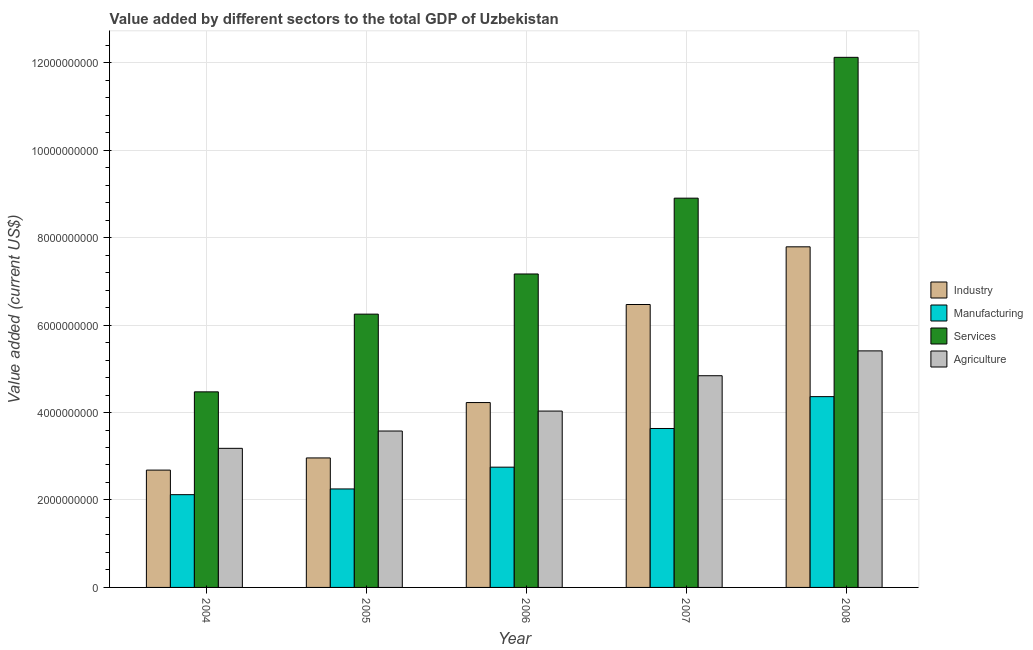How many different coloured bars are there?
Keep it short and to the point. 4. How many bars are there on the 1st tick from the left?
Offer a very short reply. 4. How many bars are there on the 5th tick from the right?
Keep it short and to the point. 4. What is the value added by services sector in 2004?
Provide a short and direct response. 4.47e+09. Across all years, what is the maximum value added by services sector?
Provide a succinct answer. 1.21e+1. Across all years, what is the minimum value added by manufacturing sector?
Provide a succinct answer. 2.12e+09. What is the total value added by manufacturing sector in the graph?
Your answer should be compact. 1.51e+1. What is the difference between the value added by manufacturing sector in 2004 and that in 2006?
Ensure brevity in your answer.  -6.29e+08. What is the difference between the value added by agricultural sector in 2005 and the value added by services sector in 2007?
Make the answer very short. -1.26e+09. What is the average value added by agricultural sector per year?
Make the answer very short. 4.21e+09. In the year 2008, what is the difference between the value added by manufacturing sector and value added by industrial sector?
Make the answer very short. 0. What is the ratio of the value added by agricultural sector in 2005 to that in 2006?
Provide a succinct answer. 0.89. Is the difference between the value added by industrial sector in 2004 and 2008 greater than the difference between the value added by services sector in 2004 and 2008?
Offer a terse response. No. What is the difference between the highest and the second highest value added by services sector?
Give a very brief answer. 3.22e+09. What is the difference between the highest and the lowest value added by agricultural sector?
Provide a short and direct response. 2.23e+09. What does the 1st bar from the left in 2005 represents?
Offer a terse response. Industry. What does the 3rd bar from the right in 2005 represents?
Keep it short and to the point. Manufacturing. Is it the case that in every year, the sum of the value added by industrial sector and value added by manufacturing sector is greater than the value added by services sector?
Your answer should be very brief. No. Are all the bars in the graph horizontal?
Offer a terse response. No. Does the graph contain any zero values?
Give a very brief answer. No. How are the legend labels stacked?
Give a very brief answer. Vertical. What is the title of the graph?
Your answer should be compact. Value added by different sectors to the total GDP of Uzbekistan. Does "Third 20% of population" appear as one of the legend labels in the graph?
Your answer should be very brief. No. What is the label or title of the X-axis?
Make the answer very short. Year. What is the label or title of the Y-axis?
Provide a succinct answer. Value added (current US$). What is the Value added (current US$) of Industry in 2004?
Offer a terse response. 2.68e+09. What is the Value added (current US$) in Manufacturing in 2004?
Your answer should be compact. 2.12e+09. What is the Value added (current US$) of Services in 2004?
Keep it short and to the point. 4.47e+09. What is the Value added (current US$) of Agriculture in 2004?
Ensure brevity in your answer.  3.18e+09. What is the Value added (current US$) in Industry in 2005?
Your answer should be compact. 2.96e+09. What is the Value added (current US$) of Manufacturing in 2005?
Provide a short and direct response. 2.25e+09. What is the Value added (current US$) of Services in 2005?
Your answer should be very brief. 6.25e+09. What is the Value added (current US$) in Agriculture in 2005?
Keep it short and to the point. 3.58e+09. What is the Value added (current US$) in Industry in 2006?
Make the answer very short. 4.23e+09. What is the Value added (current US$) of Manufacturing in 2006?
Your response must be concise. 2.75e+09. What is the Value added (current US$) in Services in 2006?
Your answer should be compact. 7.17e+09. What is the Value added (current US$) of Agriculture in 2006?
Give a very brief answer. 4.03e+09. What is the Value added (current US$) of Industry in 2007?
Provide a succinct answer. 6.47e+09. What is the Value added (current US$) of Manufacturing in 2007?
Provide a short and direct response. 3.64e+09. What is the Value added (current US$) of Services in 2007?
Give a very brief answer. 8.90e+09. What is the Value added (current US$) of Agriculture in 2007?
Provide a succinct answer. 4.84e+09. What is the Value added (current US$) in Industry in 2008?
Provide a succinct answer. 7.79e+09. What is the Value added (current US$) in Manufacturing in 2008?
Make the answer very short. 4.36e+09. What is the Value added (current US$) in Services in 2008?
Keep it short and to the point. 1.21e+1. What is the Value added (current US$) in Agriculture in 2008?
Keep it short and to the point. 5.41e+09. Across all years, what is the maximum Value added (current US$) in Industry?
Your response must be concise. 7.79e+09. Across all years, what is the maximum Value added (current US$) in Manufacturing?
Make the answer very short. 4.36e+09. Across all years, what is the maximum Value added (current US$) in Services?
Give a very brief answer. 1.21e+1. Across all years, what is the maximum Value added (current US$) of Agriculture?
Ensure brevity in your answer.  5.41e+09. Across all years, what is the minimum Value added (current US$) in Industry?
Your answer should be compact. 2.68e+09. Across all years, what is the minimum Value added (current US$) of Manufacturing?
Your answer should be very brief. 2.12e+09. Across all years, what is the minimum Value added (current US$) in Services?
Make the answer very short. 4.47e+09. Across all years, what is the minimum Value added (current US$) in Agriculture?
Your answer should be compact. 3.18e+09. What is the total Value added (current US$) in Industry in the graph?
Your answer should be very brief. 2.41e+1. What is the total Value added (current US$) of Manufacturing in the graph?
Offer a terse response. 1.51e+1. What is the total Value added (current US$) in Services in the graph?
Provide a succinct answer. 3.89e+1. What is the total Value added (current US$) of Agriculture in the graph?
Your answer should be compact. 2.10e+1. What is the difference between the Value added (current US$) of Industry in 2004 and that in 2005?
Offer a very short reply. -2.78e+08. What is the difference between the Value added (current US$) in Manufacturing in 2004 and that in 2005?
Ensure brevity in your answer.  -1.31e+08. What is the difference between the Value added (current US$) in Services in 2004 and that in 2005?
Ensure brevity in your answer.  -1.78e+09. What is the difference between the Value added (current US$) of Agriculture in 2004 and that in 2005?
Your answer should be compact. -3.96e+08. What is the difference between the Value added (current US$) in Industry in 2004 and that in 2006?
Ensure brevity in your answer.  -1.54e+09. What is the difference between the Value added (current US$) of Manufacturing in 2004 and that in 2006?
Provide a short and direct response. -6.29e+08. What is the difference between the Value added (current US$) of Services in 2004 and that in 2006?
Make the answer very short. -2.70e+09. What is the difference between the Value added (current US$) of Agriculture in 2004 and that in 2006?
Give a very brief answer. -8.52e+08. What is the difference between the Value added (current US$) in Industry in 2004 and that in 2007?
Make the answer very short. -3.79e+09. What is the difference between the Value added (current US$) of Manufacturing in 2004 and that in 2007?
Provide a succinct answer. -1.51e+09. What is the difference between the Value added (current US$) of Services in 2004 and that in 2007?
Provide a short and direct response. -4.43e+09. What is the difference between the Value added (current US$) of Agriculture in 2004 and that in 2007?
Give a very brief answer. -1.66e+09. What is the difference between the Value added (current US$) in Industry in 2004 and that in 2008?
Provide a succinct answer. -5.11e+09. What is the difference between the Value added (current US$) in Manufacturing in 2004 and that in 2008?
Keep it short and to the point. -2.24e+09. What is the difference between the Value added (current US$) of Services in 2004 and that in 2008?
Provide a short and direct response. -7.65e+09. What is the difference between the Value added (current US$) of Agriculture in 2004 and that in 2008?
Keep it short and to the point. -2.23e+09. What is the difference between the Value added (current US$) of Industry in 2005 and that in 2006?
Your answer should be very brief. -1.27e+09. What is the difference between the Value added (current US$) of Manufacturing in 2005 and that in 2006?
Give a very brief answer. -4.98e+08. What is the difference between the Value added (current US$) in Services in 2005 and that in 2006?
Offer a very short reply. -9.18e+08. What is the difference between the Value added (current US$) of Agriculture in 2005 and that in 2006?
Make the answer very short. -4.56e+08. What is the difference between the Value added (current US$) in Industry in 2005 and that in 2007?
Your response must be concise. -3.51e+09. What is the difference between the Value added (current US$) in Manufacturing in 2005 and that in 2007?
Provide a short and direct response. -1.38e+09. What is the difference between the Value added (current US$) of Services in 2005 and that in 2007?
Your answer should be very brief. -2.65e+09. What is the difference between the Value added (current US$) in Agriculture in 2005 and that in 2007?
Your answer should be compact. -1.26e+09. What is the difference between the Value added (current US$) in Industry in 2005 and that in 2008?
Ensure brevity in your answer.  -4.83e+09. What is the difference between the Value added (current US$) in Manufacturing in 2005 and that in 2008?
Give a very brief answer. -2.11e+09. What is the difference between the Value added (current US$) of Services in 2005 and that in 2008?
Ensure brevity in your answer.  -5.87e+09. What is the difference between the Value added (current US$) in Agriculture in 2005 and that in 2008?
Keep it short and to the point. -1.83e+09. What is the difference between the Value added (current US$) in Industry in 2006 and that in 2007?
Provide a succinct answer. -2.24e+09. What is the difference between the Value added (current US$) in Manufacturing in 2006 and that in 2007?
Provide a succinct answer. -8.85e+08. What is the difference between the Value added (current US$) in Services in 2006 and that in 2007?
Provide a short and direct response. -1.73e+09. What is the difference between the Value added (current US$) of Agriculture in 2006 and that in 2007?
Give a very brief answer. -8.08e+08. What is the difference between the Value added (current US$) of Industry in 2006 and that in 2008?
Keep it short and to the point. -3.56e+09. What is the difference between the Value added (current US$) in Manufacturing in 2006 and that in 2008?
Your answer should be compact. -1.61e+09. What is the difference between the Value added (current US$) in Services in 2006 and that in 2008?
Make the answer very short. -4.95e+09. What is the difference between the Value added (current US$) in Agriculture in 2006 and that in 2008?
Your answer should be very brief. -1.38e+09. What is the difference between the Value added (current US$) in Industry in 2007 and that in 2008?
Ensure brevity in your answer.  -1.32e+09. What is the difference between the Value added (current US$) in Manufacturing in 2007 and that in 2008?
Make the answer very short. -7.29e+08. What is the difference between the Value added (current US$) of Services in 2007 and that in 2008?
Offer a terse response. -3.22e+09. What is the difference between the Value added (current US$) in Agriculture in 2007 and that in 2008?
Make the answer very short. -5.68e+08. What is the difference between the Value added (current US$) in Industry in 2004 and the Value added (current US$) in Manufacturing in 2005?
Your answer should be very brief. 4.31e+08. What is the difference between the Value added (current US$) in Industry in 2004 and the Value added (current US$) in Services in 2005?
Provide a short and direct response. -3.57e+09. What is the difference between the Value added (current US$) in Industry in 2004 and the Value added (current US$) in Agriculture in 2005?
Ensure brevity in your answer.  -8.93e+08. What is the difference between the Value added (current US$) in Manufacturing in 2004 and the Value added (current US$) in Services in 2005?
Your answer should be compact. -4.13e+09. What is the difference between the Value added (current US$) in Manufacturing in 2004 and the Value added (current US$) in Agriculture in 2005?
Your response must be concise. -1.46e+09. What is the difference between the Value added (current US$) in Services in 2004 and the Value added (current US$) in Agriculture in 2005?
Offer a terse response. 8.96e+08. What is the difference between the Value added (current US$) of Industry in 2004 and the Value added (current US$) of Manufacturing in 2006?
Provide a succinct answer. -6.70e+07. What is the difference between the Value added (current US$) in Industry in 2004 and the Value added (current US$) in Services in 2006?
Your answer should be very brief. -4.49e+09. What is the difference between the Value added (current US$) in Industry in 2004 and the Value added (current US$) in Agriculture in 2006?
Offer a terse response. -1.35e+09. What is the difference between the Value added (current US$) in Manufacturing in 2004 and the Value added (current US$) in Services in 2006?
Your response must be concise. -5.05e+09. What is the difference between the Value added (current US$) in Manufacturing in 2004 and the Value added (current US$) in Agriculture in 2006?
Ensure brevity in your answer.  -1.91e+09. What is the difference between the Value added (current US$) in Services in 2004 and the Value added (current US$) in Agriculture in 2006?
Make the answer very short. 4.40e+08. What is the difference between the Value added (current US$) in Industry in 2004 and the Value added (current US$) in Manufacturing in 2007?
Give a very brief answer. -9.52e+08. What is the difference between the Value added (current US$) of Industry in 2004 and the Value added (current US$) of Services in 2007?
Provide a succinct answer. -6.22e+09. What is the difference between the Value added (current US$) in Industry in 2004 and the Value added (current US$) in Agriculture in 2007?
Offer a very short reply. -2.16e+09. What is the difference between the Value added (current US$) of Manufacturing in 2004 and the Value added (current US$) of Services in 2007?
Keep it short and to the point. -6.78e+09. What is the difference between the Value added (current US$) of Manufacturing in 2004 and the Value added (current US$) of Agriculture in 2007?
Keep it short and to the point. -2.72e+09. What is the difference between the Value added (current US$) in Services in 2004 and the Value added (current US$) in Agriculture in 2007?
Offer a very short reply. -3.69e+08. What is the difference between the Value added (current US$) of Industry in 2004 and the Value added (current US$) of Manufacturing in 2008?
Offer a terse response. -1.68e+09. What is the difference between the Value added (current US$) of Industry in 2004 and the Value added (current US$) of Services in 2008?
Offer a very short reply. -9.44e+09. What is the difference between the Value added (current US$) in Industry in 2004 and the Value added (current US$) in Agriculture in 2008?
Keep it short and to the point. -2.73e+09. What is the difference between the Value added (current US$) of Manufacturing in 2004 and the Value added (current US$) of Services in 2008?
Make the answer very short. -1.00e+1. What is the difference between the Value added (current US$) of Manufacturing in 2004 and the Value added (current US$) of Agriculture in 2008?
Ensure brevity in your answer.  -3.29e+09. What is the difference between the Value added (current US$) in Services in 2004 and the Value added (current US$) in Agriculture in 2008?
Offer a terse response. -9.37e+08. What is the difference between the Value added (current US$) of Industry in 2005 and the Value added (current US$) of Manufacturing in 2006?
Your answer should be very brief. 2.11e+08. What is the difference between the Value added (current US$) of Industry in 2005 and the Value added (current US$) of Services in 2006?
Ensure brevity in your answer.  -4.21e+09. What is the difference between the Value added (current US$) of Industry in 2005 and the Value added (current US$) of Agriculture in 2006?
Offer a very short reply. -1.07e+09. What is the difference between the Value added (current US$) of Manufacturing in 2005 and the Value added (current US$) of Services in 2006?
Keep it short and to the point. -4.92e+09. What is the difference between the Value added (current US$) in Manufacturing in 2005 and the Value added (current US$) in Agriculture in 2006?
Your answer should be compact. -1.78e+09. What is the difference between the Value added (current US$) of Services in 2005 and the Value added (current US$) of Agriculture in 2006?
Your answer should be compact. 2.22e+09. What is the difference between the Value added (current US$) in Industry in 2005 and the Value added (current US$) in Manufacturing in 2007?
Keep it short and to the point. -6.73e+08. What is the difference between the Value added (current US$) of Industry in 2005 and the Value added (current US$) of Services in 2007?
Offer a terse response. -5.94e+09. What is the difference between the Value added (current US$) in Industry in 2005 and the Value added (current US$) in Agriculture in 2007?
Provide a succinct answer. -1.88e+09. What is the difference between the Value added (current US$) of Manufacturing in 2005 and the Value added (current US$) of Services in 2007?
Your response must be concise. -6.65e+09. What is the difference between the Value added (current US$) in Manufacturing in 2005 and the Value added (current US$) in Agriculture in 2007?
Provide a short and direct response. -2.59e+09. What is the difference between the Value added (current US$) in Services in 2005 and the Value added (current US$) in Agriculture in 2007?
Provide a short and direct response. 1.41e+09. What is the difference between the Value added (current US$) in Industry in 2005 and the Value added (current US$) in Manufacturing in 2008?
Your answer should be very brief. -1.40e+09. What is the difference between the Value added (current US$) of Industry in 2005 and the Value added (current US$) of Services in 2008?
Provide a short and direct response. -9.16e+09. What is the difference between the Value added (current US$) of Industry in 2005 and the Value added (current US$) of Agriculture in 2008?
Your answer should be compact. -2.45e+09. What is the difference between the Value added (current US$) of Manufacturing in 2005 and the Value added (current US$) of Services in 2008?
Provide a succinct answer. -9.87e+09. What is the difference between the Value added (current US$) in Manufacturing in 2005 and the Value added (current US$) in Agriculture in 2008?
Your answer should be compact. -3.16e+09. What is the difference between the Value added (current US$) in Services in 2005 and the Value added (current US$) in Agriculture in 2008?
Your response must be concise. 8.40e+08. What is the difference between the Value added (current US$) of Industry in 2006 and the Value added (current US$) of Manufacturing in 2007?
Ensure brevity in your answer.  5.93e+08. What is the difference between the Value added (current US$) in Industry in 2006 and the Value added (current US$) in Services in 2007?
Keep it short and to the point. -4.67e+09. What is the difference between the Value added (current US$) in Industry in 2006 and the Value added (current US$) in Agriculture in 2007?
Your response must be concise. -6.13e+08. What is the difference between the Value added (current US$) of Manufacturing in 2006 and the Value added (current US$) of Services in 2007?
Your answer should be compact. -6.15e+09. What is the difference between the Value added (current US$) of Manufacturing in 2006 and the Value added (current US$) of Agriculture in 2007?
Keep it short and to the point. -2.09e+09. What is the difference between the Value added (current US$) of Services in 2006 and the Value added (current US$) of Agriculture in 2007?
Your response must be concise. 2.33e+09. What is the difference between the Value added (current US$) of Industry in 2006 and the Value added (current US$) of Manufacturing in 2008?
Offer a very short reply. -1.35e+08. What is the difference between the Value added (current US$) of Industry in 2006 and the Value added (current US$) of Services in 2008?
Give a very brief answer. -7.90e+09. What is the difference between the Value added (current US$) in Industry in 2006 and the Value added (current US$) in Agriculture in 2008?
Offer a terse response. -1.18e+09. What is the difference between the Value added (current US$) of Manufacturing in 2006 and the Value added (current US$) of Services in 2008?
Ensure brevity in your answer.  -9.37e+09. What is the difference between the Value added (current US$) in Manufacturing in 2006 and the Value added (current US$) in Agriculture in 2008?
Offer a very short reply. -2.66e+09. What is the difference between the Value added (current US$) of Services in 2006 and the Value added (current US$) of Agriculture in 2008?
Provide a short and direct response. 1.76e+09. What is the difference between the Value added (current US$) of Industry in 2007 and the Value added (current US$) of Manufacturing in 2008?
Your answer should be very brief. 2.11e+09. What is the difference between the Value added (current US$) in Industry in 2007 and the Value added (current US$) in Services in 2008?
Ensure brevity in your answer.  -5.65e+09. What is the difference between the Value added (current US$) in Industry in 2007 and the Value added (current US$) in Agriculture in 2008?
Your answer should be compact. 1.06e+09. What is the difference between the Value added (current US$) in Manufacturing in 2007 and the Value added (current US$) in Services in 2008?
Ensure brevity in your answer.  -8.49e+09. What is the difference between the Value added (current US$) of Manufacturing in 2007 and the Value added (current US$) of Agriculture in 2008?
Ensure brevity in your answer.  -1.77e+09. What is the difference between the Value added (current US$) of Services in 2007 and the Value added (current US$) of Agriculture in 2008?
Offer a terse response. 3.49e+09. What is the average Value added (current US$) of Industry per year?
Keep it short and to the point. 4.83e+09. What is the average Value added (current US$) of Manufacturing per year?
Offer a very short reply. 3.02e+09. What is the average Value added (current US$) of Services per year?
Provide a succinct answer. 7.78e+09. What is the average Value added (current US$) in Agriculture per year?
Your answer should be very brief. 4.21e+09. In the year 2004, what is the difference between the Value added (current US$) in Industry and Value added (current US$) in Manufacturing?
Your answer should be compact. 5.62e+08. In the year 2004, what is the difference between the Value added (current US$) of Industry and Value added (current US$) of Services?
Offer a very short reply. -1.79e+09. In the year 2004, what is the difference between the Value added (current US$) of Industry and Value added (current US$) of Agriculture?
Keep it short and to the point. -4.98e+08. In the year 2004, what is the difference between the Value added (current US$) in Manufacturing and Value added (current US$) in Services?
Offer a terse response. -2.35e+09. In the year 2004, what is the difference between the Value added (current US$) in Manufacturing and Value added (current US$) in Agriculture?
Offer a terse response. -1.06e+09. In the year 2004, what is the difference between the Value added (current US$) of Services and Value added (current US$) of Agriculture?
Offer a very short reply. 1.29e+09. In the year 2005, what is the difference between the Value added (current US$) of Industry and Value added (current US$) of Manufacturing?
Your answer should be compact. 7.09e+08. In the year 2005, what is the difference between the Value added (current US$) in Industry and Value added (current US$) in Services?
Give a very brief answer. -3.29e+09. In the year 2005, what is the difference between the Value added (current US$) of Industry and Value added (current US$) of Agriculture?
Offer a terse response. -6.15e+08. In the year 2005, what is the difference between the Value added (current US$) in Manufacturing and Value added (current US$) in Services?
Keep it short and to the point. -4.00e+09. In the year 2005, what is the difference between the Value added (current US$) of Manufacturing and Value added (current US$) of Agriculture?
Keep it short and to the point. -1.32e+09. In the year 2005, what is the difference between the Value added (current US$) of Services and Value added (current US$) of Agriculture?
Provide a short and direct response. 2.67e+09. In the year 2006, what is the difference between the Value added (current US$) of Industry and Value added (current US$) of Manufacturing?
Your answer should be very brief. 1.48e+09. In the year 2006, what is the difference between the Value added (current US$) in Industry and Value added (current US$) in Services?
Provide a short and direct response. -2.94e+09. In the year 2006, what is the difference between the Value added (current US$) of Industry and Value added (current US$) of Agriculture?
Ensure brevity in your answer.  1.95e+08. In the year 2006, what is the difference between the Value added (current US$) of Manufacturing and Value added (current US$) of Services?
Make the answer very short. -4.42e+09. In the year 2006, what is the difference between the Value added (current US$) in Manufacturing and Value added (current US$) in Agriculture?
Your answer should be compact. -1.28e+09. In the year 2006, what is the difference between the Value added (current US$) in Services and Value added (current US$) in Agriculture?
Offer a very short reply. 3.14e+09. In the year 2007, what is the difference between the Value added (current US$) in Industry and Value added (current US$) in Manufacturing?
Give a very brief answer. 2.84e+09. In the year 2007, what is the difference between the Value added (current US$) of Industry and Value added (current US$) of Services?
Provide a short and direct response. -2.43e+09. In the year 2007, what is the difference between the Value added (current US$) of Industry and Value added (current US$) of Agriculture?
Offer a terse response. 1.63e+09. In the year 2007, what is the difference between the Value added (current US$) in Manufacturing and Value added (current US$) in Services?
Give a very brief answer. -5.27e+09. In the year 2007, what is the difference between the Value added (current US$) in Manufacturing and Value added (current US$) in Agriculture?
Keep it short and to the point. -1.21e+09. In the year 2007, what is the difference between the Value added (current US$) of Services and Value added (current US$) of Agriculture?
Offer a very short reply. 4.06e+09. In the year 2008, what is the difference between the Value added (current US$) in Industry and Value added (current US$) in Manufacturing?
Keep it short and to the point. 3.43e+09. In the year 2008, what is the difference between the Value added (current US$) of Industry and Value added (current US$) of Services?
Your response must be concise. -4.33e+09. In the year 2008, what is the difference between the Value added (current US$) of Industry and Value added (current US$) of Agriculture?
Your answer should be compact. 2.38e+09. In the year 2008, what is the difference between the Value added (current US$) in Manufacturing and Value added (current US$) in Services?
Offer a terse response. -7.76e+09. In the year 2008, what is the difference between the Value added (current US$) in Manufacturing and Value added (current US$) in Agriculture?
Your answer should be compact. -1.05e+09. In the year 2008, what is the difference between the Value added (current US$) of Services and Value added (current US$) of Agriculture?
Make the answer very short. 6.71e+09. What is the ratio of the Value added (current US$) in Industry in 2004 to that in 2005?
Keep it short and to the point. 0.91. What is the ratio of the Value added (current US$) in Manufacturing in 2004 to that in 2005?
Give a very brief answer. 0.94. What is the ratio of the Value added (current US$) of Services in 2004 to that in 2005?
Give a very brief answer. 0.72. What is the ratio of the Value added (current US$) in Agriculture in 2004 to that in 2005?
Your answer should be compact. 0.89. What is the ratio of the Value added (current US$) in Industry in 2004 to that in 2006?
Your answer should be compact. 0.63. What is the ratio of the Value added (current US$) of Manufacturing in 2004 to that in 2006?
Give a very brief answer. 0.77. What is the ratio of the Value added (current US$) of Services in 2004 to that in 2006?
Make the answer very short. 0.62. What is the ratio of the Value added (current US$) in Agriculture in 2004 to that in 2006?
Ensure brevity in your answer.  0.79. What is the ratio of the Value added (current US$) of Industry in 2004 to that in 2007?
Your answer should be very brief. 0.41. What is the ratio of the Value added (current US$) of Manufacturing in 2004 to that in 2007?
Provide a succinct answer. 0.58. What is the ratio of the Value added (current US$) in Services in 2004 to that in 2007?
Offer a terse response. 0.5. What is the ratio of the Value added (current US$) in Agriculture in 2004 to that in 2007?
Your response must be concise. 0.66. What is the ratio of the Value added (current US$) of Industry in 2004 to that in 2008?
Your response must be concise. 0.34. What is the ratio of the Value added (current US$) in Manufacturing in 2004 to that in 2008?
Your response must be concise. 0.49. What is the ratio of the Value added (current US$) of Services in 2004 to that in 2008?
Offer a very short reply. 0.37. What is the ratio of the Value added (current US$) of Agriculture in 2004 to that in 2008?
Offer a very short reply. 0.59. What is the ratio of the Value added (current US$) of Industry in 2005 to that in 2006?
Provide a short and direct response. 0.7. What is the ratio of the Value added (current US$) in Manufacturing in 2005 to that in 2006?
Ensure brevity in your answer.  0.82. What is the ratio of the Value added (current US$) in Services in 2005 to that in 2006?
Your answer should be compact. 0.87. What is the ratio of the Value added (current US$) in Agriculture in 2005 to that in 2006?
Keep it short and to the point. 0.89. What is the ratio of the Value added (current US$) of Industry in 2005 to that in 2007?
Your response must be concise. 0.46. What is the ratio of the Value added (current US$) of Manufacturing in 2005 to that in 2007?
Give a very brief answer. 0.62. What is the ratio of the Value added (current US$) of Services in 2005 to that in 2007?
Your answer should be very brief. 0.7. What is the ratio of the Value added (current US$) in Agriculture in 2005 to that in 2007?
Ensure brevity in your answer.  0.74. What is the ratio of the Value added (current US$) in Industry in 2005 to that in 2008?
Keep it short and to the point. 0.38. What is the ratio of the Value added (current US$) in Manufacturing in 2005 to that in 2008?
Make the answer very short. 0.52. What is the ratio of the Value added (current US$) in Services in 2005 to that in 2008?
Your response must be concise. 0.52. What is the ratio of the Value added (current US$) in Agriculture in 2005 to that in 2008?
Offer a very short reply. 0.66. What is the ratio of the Value added (current US$) of Industry in 2006 to that in 2007?
Give a very brief answer. 0.65. What is the ratio of the Value added (current US$) of Manufacturing in 2006 to that in 2007?
Your answer should be very brief. 0.76. What is the ratio of the Value added (current US$) in Services in 2006 to that in 2007?
Keep it short and to the point. 0.81. What is the ratio of the Value added (current US$) in Agriculture in 2006 to that in 2007?
Your response must be concise. 0.83. What is the ratio of the Value added (current US$) in Industry in 2006 to that in 2008?
Your response must be concise. 0.54. What is the ratio of the Value added (current US$) in Manufacturing in 2006 to that in 2008?
Provide a succinct answer. 0.63. What is the ratio of the Value added (current US$) of Services in 2006 to that in 2008?
Provide a succinct answer. 0.59. What is the ratio of the Value added (current US$) of Agriculture in 2006 to that in 2008?
Offer a terse response. 0.75. What is the ratio of the Value added (current US$) in Industry in 2007 to that in 2008?
Ensure brevity in your answer.  0.83. What is the ratio of the Value added (current US$) of Manufacturing in 2007 to that in 2008?
Your answer should be compact. 0.83. What is the ratio of the Value added (current US$) in Services in 2007 to that in 2008?
Provide a succinct answer. 0.73. What is the ratio of the Value added (current US$) in Agriculture in 2007 to that in 2008?
Make the answer very short. 0.89. What is the difference between the highest and the second highest Value added (current US$) of Industry?
Make the answer very short. 1.32e+09. What is the difference between the highest and the second highest Value added (current US$) of Manufacturing?
Give a very brief answer. 7.29e+08. What is the difference between the highest and the second highest Value added (current US$) of Services?
Offer a very short reply. 3.22e+09. What is the difference between the highest and the second highest Value added (current US$) in Agriculture?
Keep it short and to the point. 5.68e+08. What is the difference between the highest and the lowest Value added (current US$) in Industry?
Offer a very short reply. 5.11e+09. What is the difference between the highest and the lowest Value added (current US$) in Manufacturing?
Your answer should be compact. 2.24e+09. What is the difference between the highest and the lowest Value added (current US$) of Services?
Your answer should be very brief. 7.65e+09. What is the difference between the highest and the lowest Value added (current US$) in Agriculture?
Your answer should be very brief. 2.23e+09. 